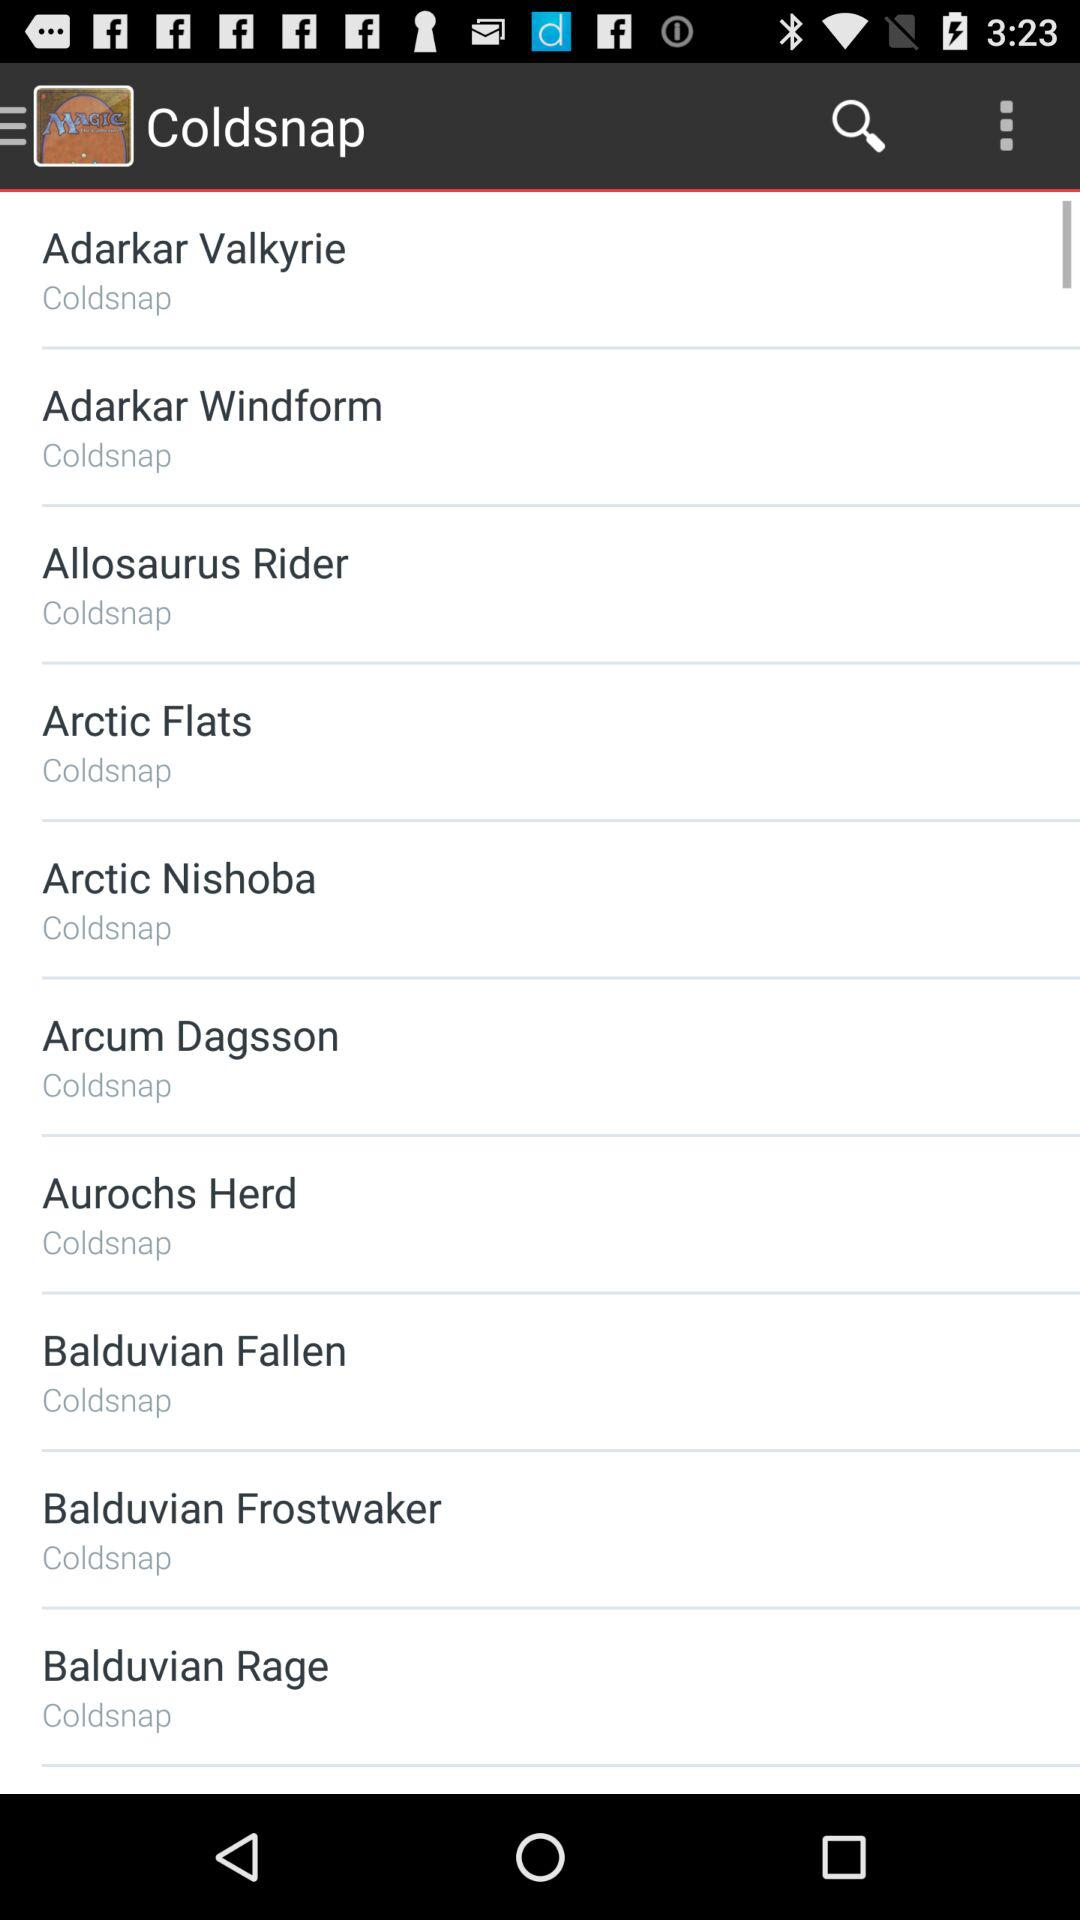What is the name of the application? The name of the application is "Magic: The Gathering Arena". 